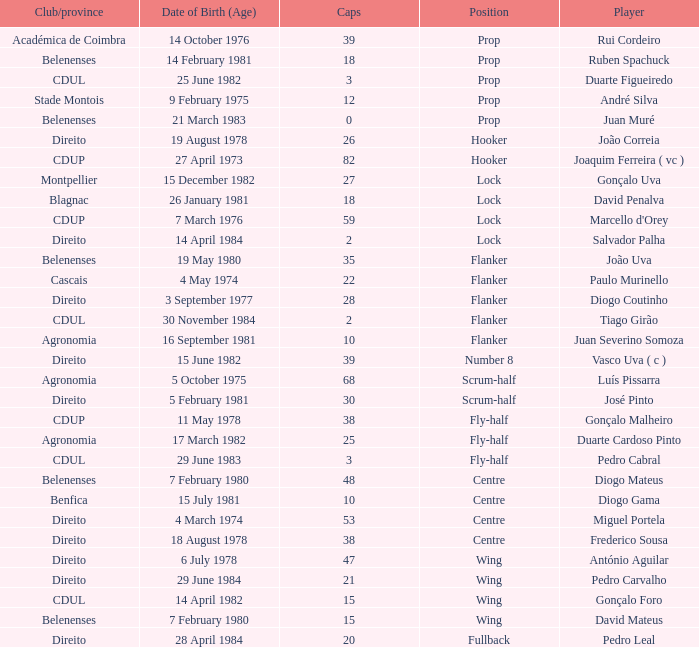Which Club/province has a Player of david penalva? Blagnac. 